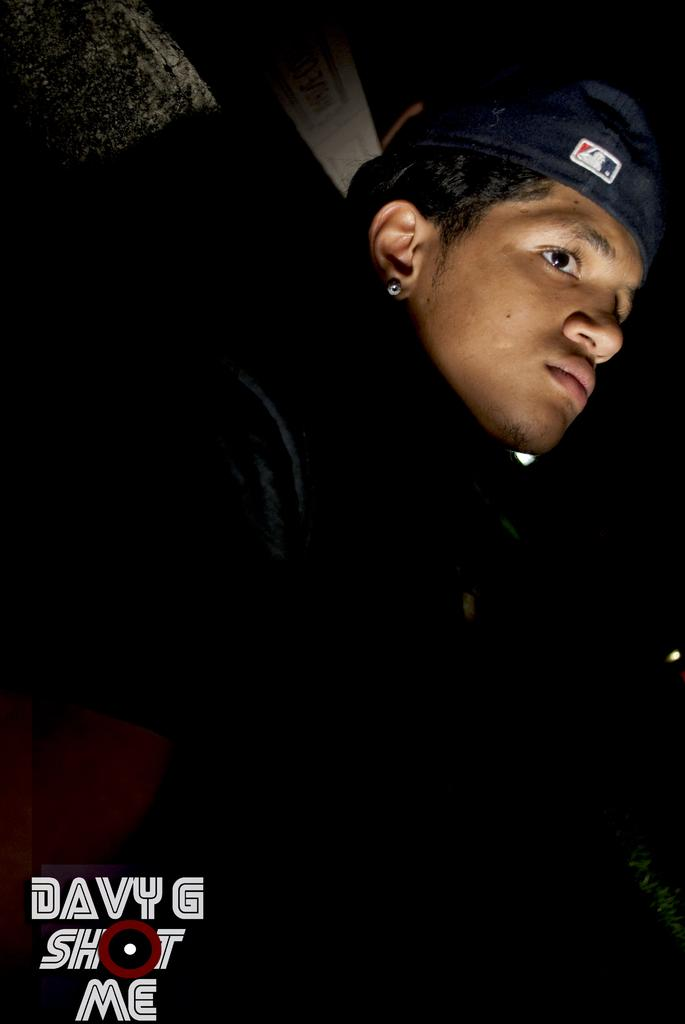Who is present in the image? There is a man in the image. What is the man wearing on his head? The man is wearing a cap. What is the man's position in relation to the ground in the image? The man is standing over a place. What type of cactus can be seen in the background of the image? There is no cactus present in the image. 